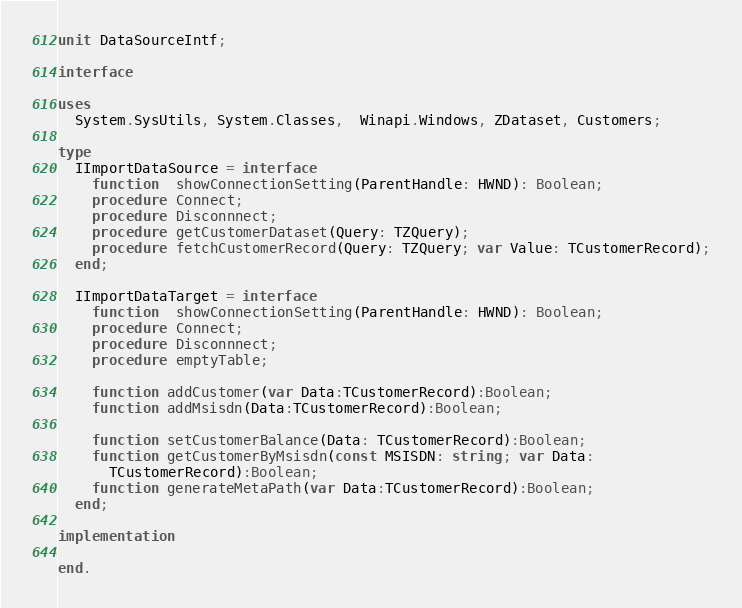Convert code to text. <code><loc_0><loc_0><loc_500><loc_500><_Pascal_>unit DataSourceIntf;

interface

uses
  System.SysUtils, System.Classes,  Winapi.Windows, ZDataset, Customers;

type
  IImportDataSource = interface
    function  showConnectionSetting(ParentHandle: HWND): Boolean;
    procedure Connect;
    procedure Disconnnect;
    procedure getCustomerDataset(Query: TZQuery);
    procedure fetchCustomerRecord(Query: TZQuery; var Value: TCustomerRecord);
  end;

  IImportDataTarget = interface
    function  showConnectionSetting(ParentHandle: HWND): Boolean;
    procedure Connect;
    procedure Disconnnect;
    procedure emptyTable;

    function addCustomer(var Data:TCustomerRecord):Boolean;
    function addMsisdn(Data:TCustomerRecord):Boolean;

    function setCustomerBalance(Data: TCustomerRecord):Boolean;
    function getCustomerByMsisdn(const MSISDN: string; var Data:
      TCustomerRecord):Boolean;
    function generateMetaPath(var Data:TCustomerRecord):Boolean;
  end;

implementation

end.
</code> 